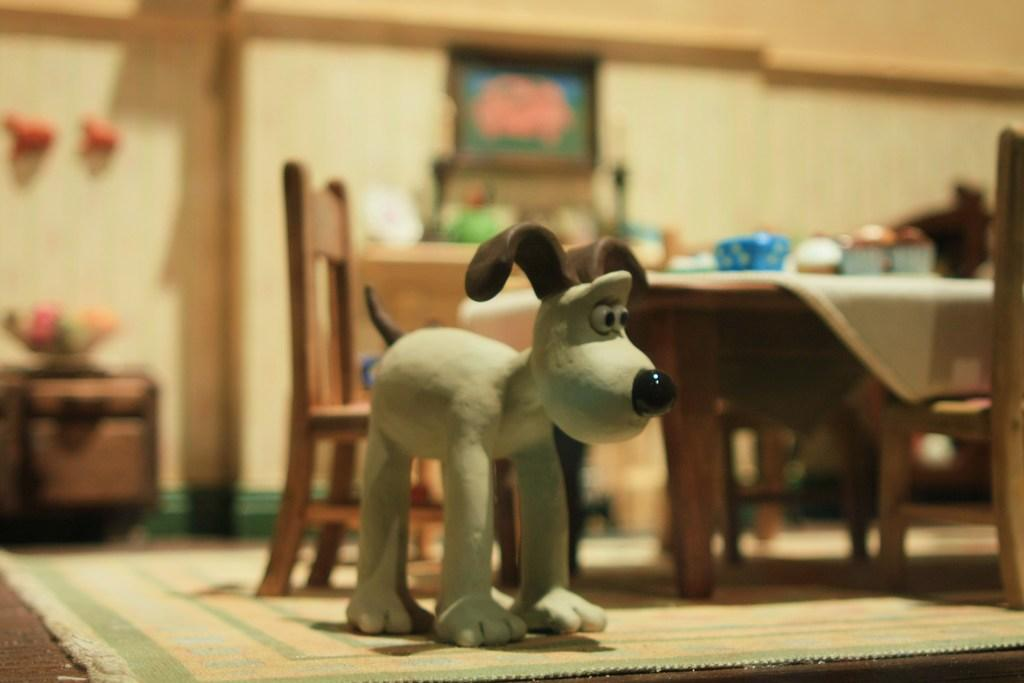What object is on the floor in the image? There is a toy on the floor. What type of furniture is present in the image? There is a chair and a table in the image. What is on the table in the image? There are bowls on the table. What can be seen in the background of the image? There is a wall with a frame and a pole in the background. Can you see any fog in the image? There is no fog present in the image. Is there a cave visible in the background of the image? There is no cave present in the image; only a wall with a frame and a pole can be seen in the background. 